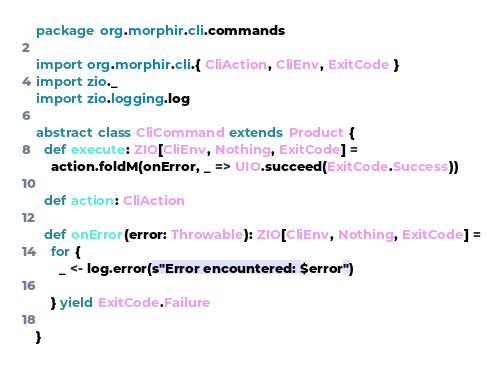<code> <loc_0><loc_0><loc_500><loc_500><_Scala_>package org.morphir.cli.commands

import org.morphir.cli.{ CliAction, CliEnv, ExitCode }
import zio._
import zio.logging.log

abstract class CliCommand extends Product {
  def execute: ZIO[CliEnv, Nothing, ExitCode] =
    action.foldM(onError, _ => UIO.succeed(ExitCode.Success))

  def action: CliAction

  def onError(error: Throwable): ZIO[CliEnv, Nothing, ExitCode] =
    for {
      _ <- log.error(s"Error encountered: $error")

    } yield ExitCode.Failure

}
</code> 